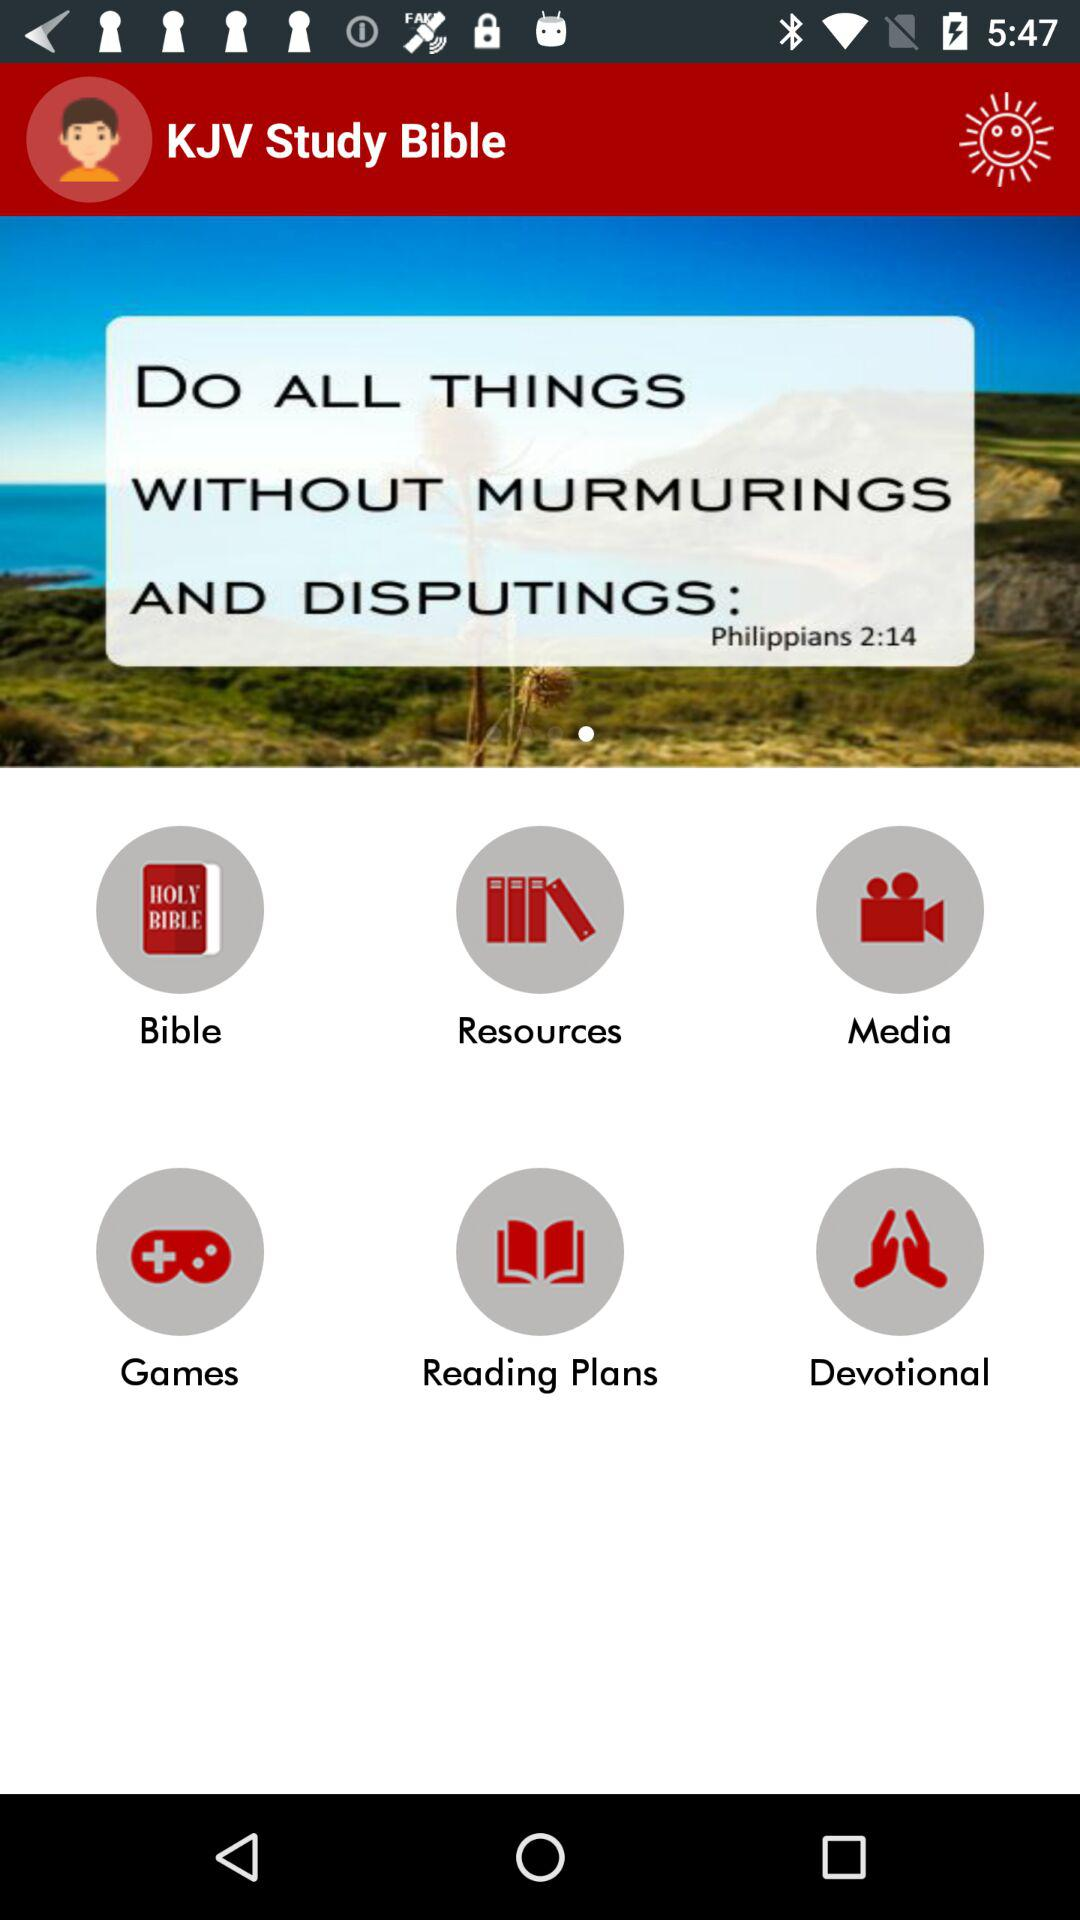What is the name of the application? The name of the application is "KJV Study Bible". 